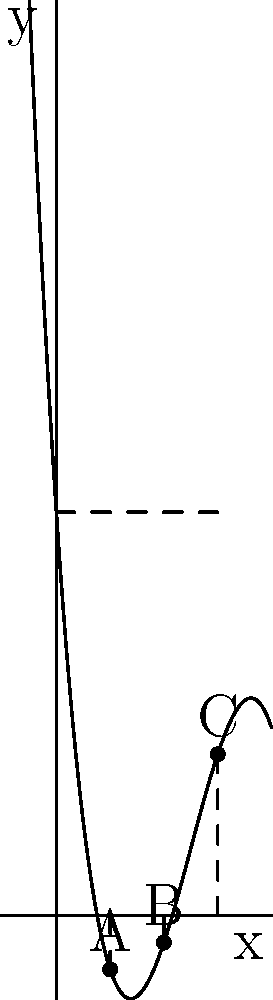In a women's rugby match, the coach wants to optimize the positions of three key players (A, B, and C) on a linear formation. The effectiveness of their positions is modeled by the polynomial function $f(x) = -0.25x^3 + 3.75x^2 - 15x + 15$, where $x$ represents the distance from the left sideline in meters, and $f(x)$ represents the player's effectiveness score. Find the optimal positions for players A, B, and C to maximize their combined effectiveness. To find the optimal positions, we need to find the roots of the derivative of the given function:

1) First, let's find the derivative of $f(x)$:
   $f'(x) = -0.75x^2 + 7.5x - 15$

2) Now, we need to find the roots of $f'(x) = 0$:
   $-0.75x^2 + 7.5x - 15 = 0$

3) This is a quadratic equation. We can solve it using the quadratic formula:
   $x = \frac{-b \pm \sqrt{b^2 - 4ac}}{2a}$

   Where $a = -0.75$, $b = 7.5$, and $c = -15$

4) Plugging these values into the quadratic formula:
   $x = \frac{-7.5 \pm \sqrt{7.5^2 - 4(-0.75)(-15)}}{2(-0.75)}$

5) Simplifying:
   $x = \frac{-7.5 \pm \sqrt{56.25 - 45}}{-1.5} = \frac{-7.5 \pm \sqrt{11.25}}{-1.5} = \frac{-7.5 \pm 3.354}{-1.5}$

6) This gives us two solutions:
   $x_1 = \frac{-7.5 + 3.354}{-1.5} \approx 2.764$
   $x_2 = \frac{-7.5 - 3.354}{-1.5} \approx 7.236$

7) These are the x-coordinates of the local maximum and minimum points on the curve.

8) For the optimal positions, we need three points. The third point will be at $x = 0$ (left sideline) or $x = 6$ (right sideline, assuming a 6-meter width).

9) Evaluating $f(0)$ and $f(6)$:
   $f(0) = 15$
   $f(6) = -0.25(6^3) + 3.75(6^2) - 15(6) + 15 = 15$

10) Since $f(6) = f(0)$, we choose $x = 6$ for symmetry.

Therefore, the optimal positions are:
Player A: $x \approx 2$ meters (rounded from 2.764)
Player B: $x = 4$ meters (midpoint between A and C)
Player C: $x = 6$ meters
Answer: A: 2m, B: 4m, C: 6m from left sideline 